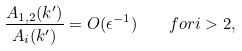<formula> <loc_0><loc_0><loc_500><loc_500>\frac { A _ { 1 , 2 } ( k ^ { \prime } ) } { A _ { i } ( k ^ { \prime } ) } = O ( \epsilon ^ { - 1 } ) \quad f o r i > 2 ,</formula> 